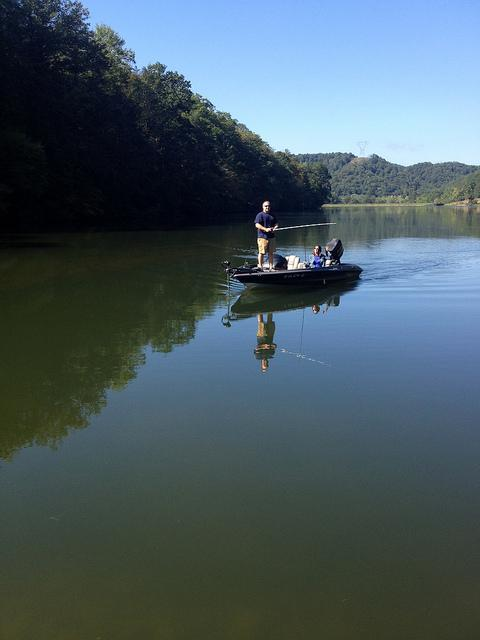How many people are sitting in the fishing boat on this day? Please explain your reasoning. two. There are two people fishing in the boat. 